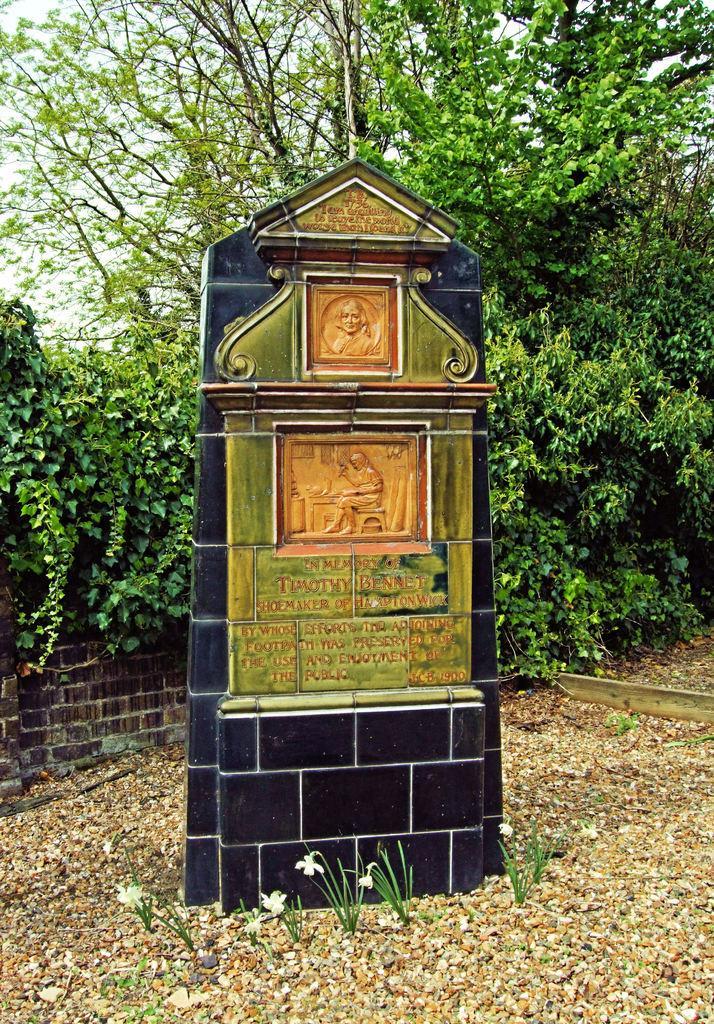Can you describe this image briefly? In this image we can see a memorial, plants, flowers, stones, wall, and trees. In the background there is sky. 